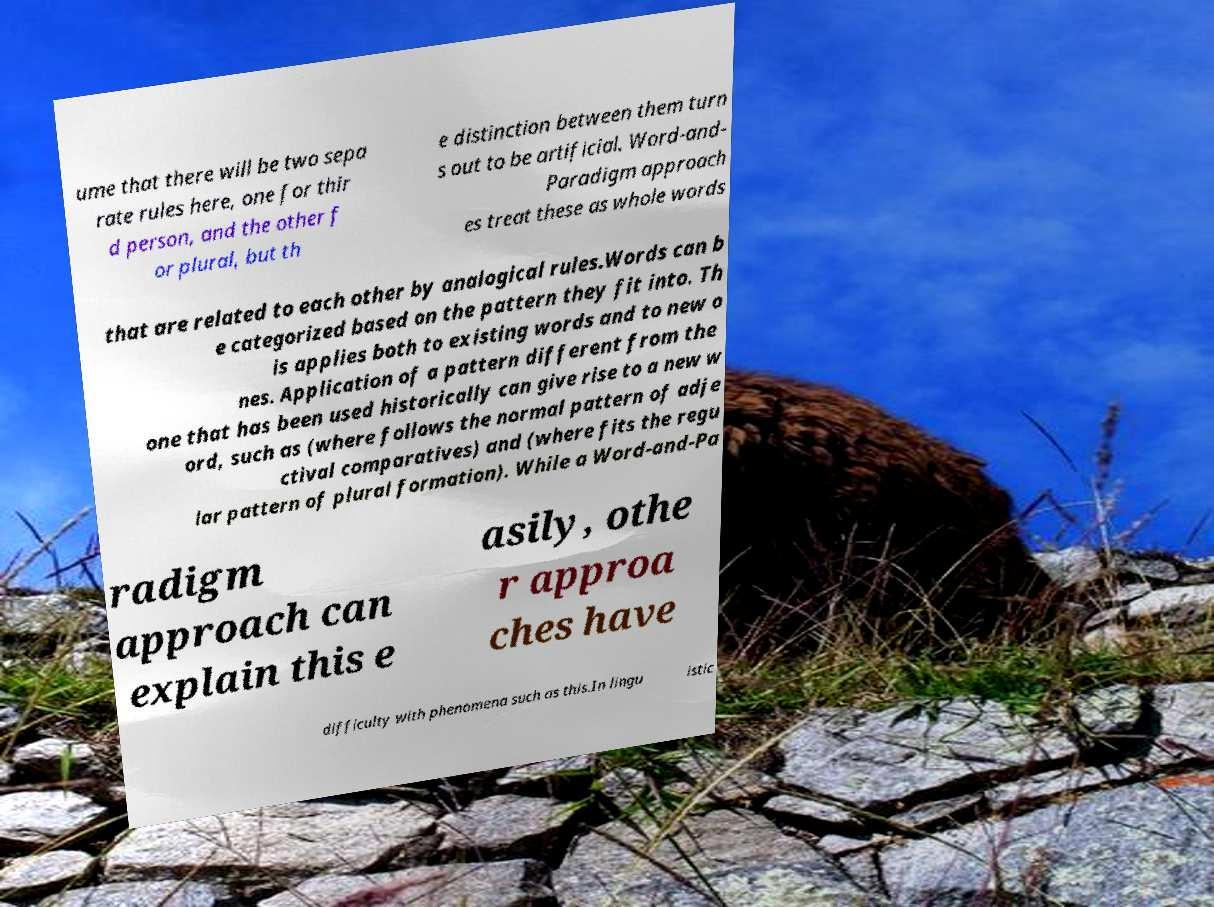Can you read and provide the text displayed in the image?This photo seems to have some interesting text. Can you extract and type it out for me? ume that there will be two sepa rate rules here, one for thir d person, and the other f or plural, but th e distinction between them turn s out to be artificial. Word-and- Paradigm approach es treat these as whole words that are related to each other by analogical rules.Words can b e categorized based on the pattern they fit into. Th is applies both to existing words and to new o nes. Application of a pattern different from the one that has been used historically can give rise to a new w ord, such as (where follows the normal pattern of adje ctival comparatives) and (where fits the regu lar pattern of plural formation). While a Word-and-Pa radigm approach can explain this e asily, othe r approa ches have difficulty with phenomena such as this.In lingu istic 